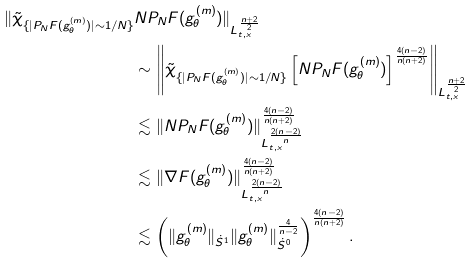<formula> <loc_0><loc_0><loc_500><loc_500>\| \tilde { \chi } _ { \{ | P _ { N } F ( g ^ { ( m ) } _ { \theta } ) | \sim 1 / N \} } & N P _ { N } F ( g ^ { ( m ) } _ { \theta } ) \| _ { L _ { t , x } ^ { \frac { n + 2 } { 2 } } } \\ & \sim \left \| \tilde { \chi } _ { \{ | P _ { N } F ( g ^ { ( m ) } _ { \theta } ) | \sim 1 / N \} } \left [ N P _ { N } F ( g ^ { ( m ) } _ { \theta } ) \right ] ^ { \frac { 4 ( n - 2 ) } { n ( n + 2 ) } } \right \| _ { L _ { t , x } ^ { \frac { n + 2 } { 2 } } } \\ & \lesssim \| N P _ { N } F ( g ^ { ( m ) } _ { \theta } ) \| _ { L _ { t , x } ^ { \frac { 2 ( n - 2 ) } { n } } } ^ { \frac { 4 ( n - 2 ) } { n ( n + 2 ) } } \\ & \lesssim \| \nabla F ( g ^ { ( m ) } _ { \theta } ) \| _ { L _ { t , x } ^ { \frac { 2 ( n - 2 ) } { n } } } ^ { \frac { 4 ( n - 2 ) } { n ( n + 2 ) } } \\ & \lesssim \left ( \| g ^ { ( m ) } _ { \theta } \| _ { \dot { S } ^ { 1 } } \| g ^ { ( m ) } _ { \theta } \| _ { \dot { S } ^ { 0 } } ^ { \frac { 4 } { n - 2 } } \right ) ^ { \frac { 4 ( n - 2 ) } { n ( n + 2 ) } } .</formula> 